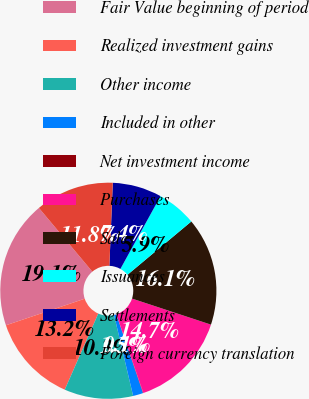Convert chart. <chart><loc_0><loc_0><loc_500><loc_500><pie_chart><fcel>Fair Value beginning of period<fcel>Realized investment gains<fcel>Other income<fcel>Included in other<fcel>Net investment income<fcel>Purchases<fcel>Sales<fcel>Issuances<fcel>Settlements<fcel>Foreign currency translation<nl><fcel>19.07%<fcel>13.22%<fcel>10.29%<fcel>1.51%<fcel>0.05%<fcel>14.68%<fcel>16.15%<fcel>5.9%<fcel>7.37%<fcel>11.76%<nl></chart> 